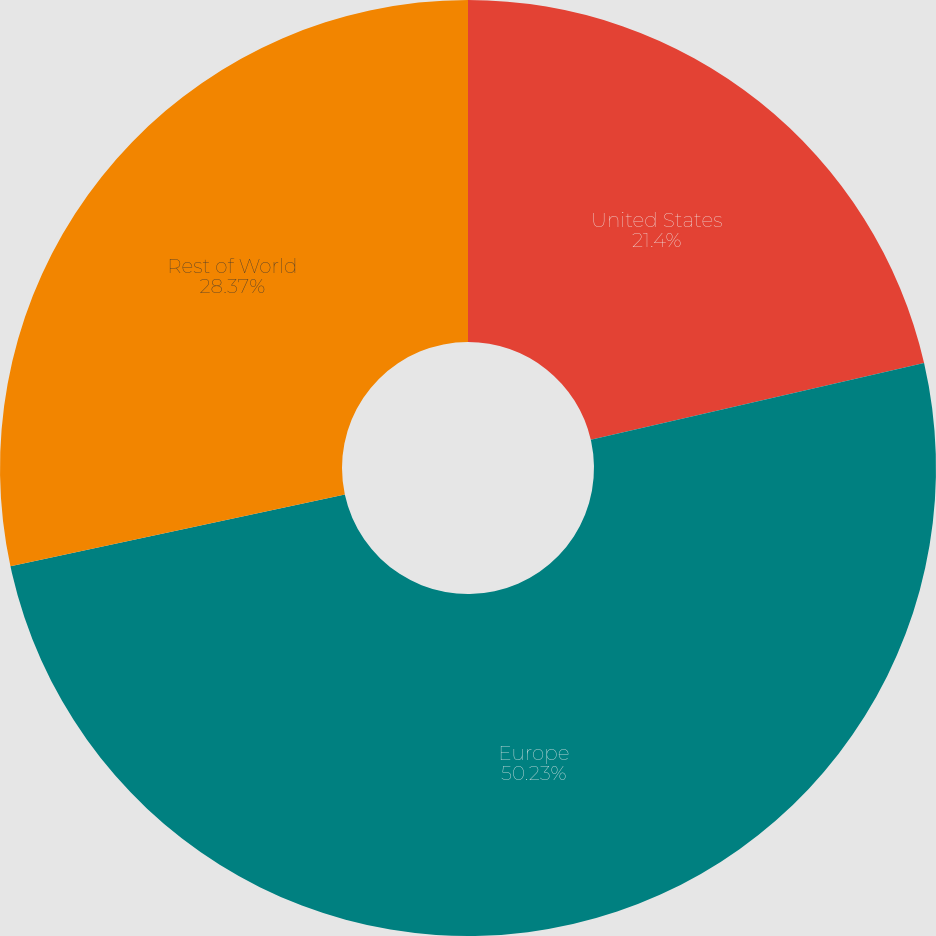Convert chart to OTSL. <chart><loc_0><loc_0><loc_500><loc_500><pie_chart><fcel>United States<fcel>Europe<fcel>Rest of World<nl><fcel>21.4%<fcel>50.23%<fcel>28.37%<nl></chart> 